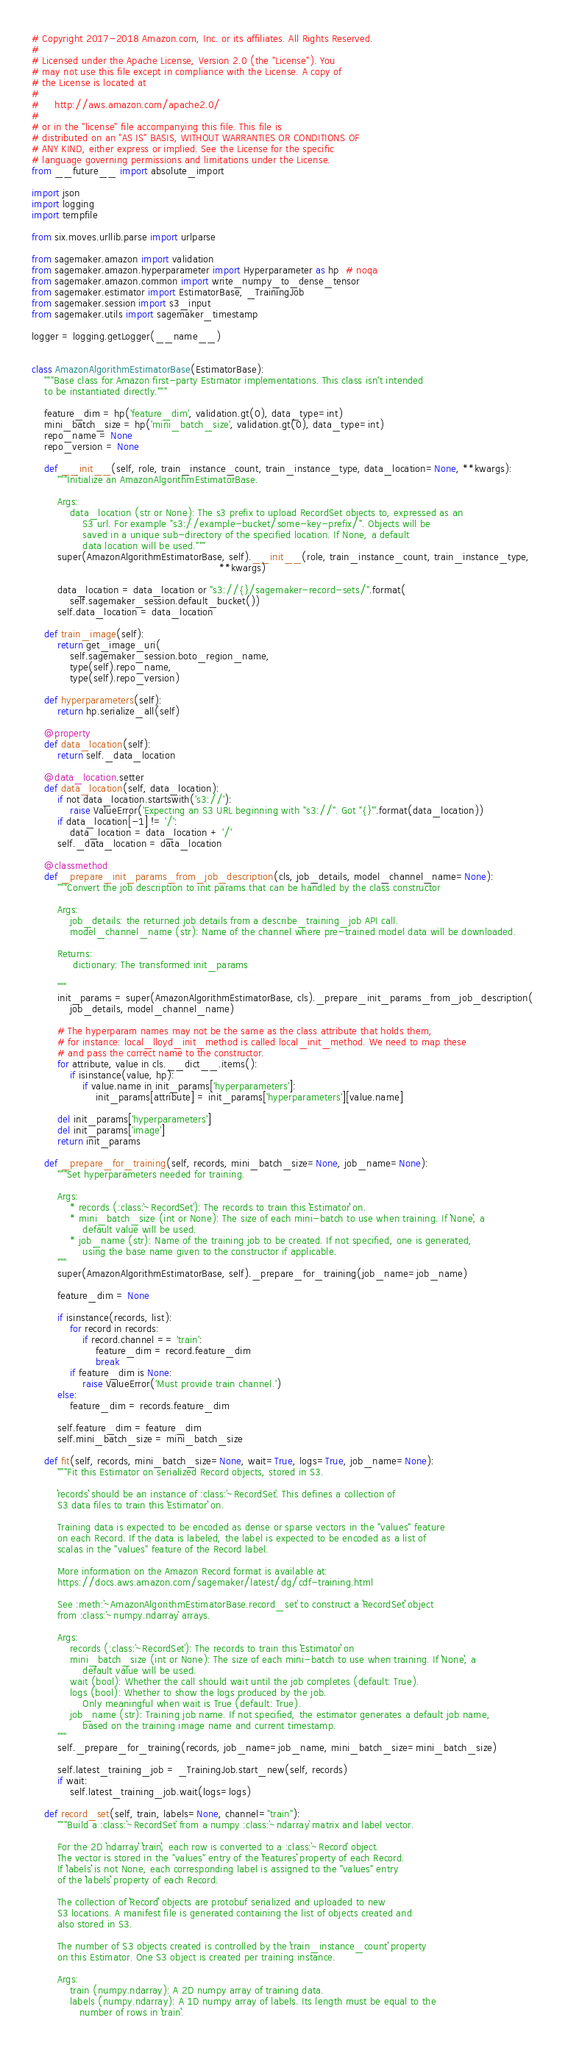<code> <loc_0><loc_0><loc_500><loc_500><_Python_># Copyright 2017-2018 Amazon.com, Inc. or its affiliates. All Rights Reserved.
#
# Licensed under the Apache License, Version 2.0 (the "License"). You
# may not use this file except in compliance with the License. A copy of
# the License is located at
#
#     http://aws.amazon.com/apache2.0/
#
# or in the "license" file accompanying this file. This file is
# distributed on an "AS IS" BASIS, WITHOUT WARRANTIES OR CONDITIONS OF
# ANY KIND, either express or implied. See the License for the specific
# language governing permissions and limitations under the License.
from __future__ import absolute_import

import json
import logging
import tempfile

from six.moves.urllib.parse import urlparse

from sagemaker.amazon import validation
from sagemaker.amazon.hyperparameter import Hyperparameter as hp  # noqa
from sagemaker.amazon.common import write_numpy_to_dense_tensor
from sagemaker.estimator import EstimatorBase, _TrainingJob
from sagemaker.session import s3_input
from sagemaker.utils import sagemaker_timestamp

logger = logging.getLogger(__name__)


class AmazonAlgorithmEstimatorBase(EstimatorBase):
    """Base class for Amazon first-party Estimator implementations. This class isn't intended
    to be instantiated directly."""

    feature_dim = hp('feature_dim', validation.gt(0), data_type=int)
    mini_batch_size = hp('mini_batch_size', validation.gt(0), data_type=int)
    repo_name = None
    repo_version = None

    def __init__(self, role, train_instance_count, train_instance_type, data_location=None, **kwargs):
        """Initialize an AmazonAlgorithmEstimatorBase.

        Args:
            data_location (str or None): The s3 prefix to upload RecordSet objects to, expressed as an
                S3 url. For example "s3://example-bucket/some-key-prefix/". Objects will be
                saved in a unique sub-directory of the specified location. If None, a default
                data location will be used."""
        super(AmazonAlgorithmEstimatorBase, self).__init__(role, train_instance_count, train_instance_type,
                                                           **kwargs)

        data_location = data_location or "s3://{}/sagemaker-record-sets/".format(
            self.sagemaker_session.default_bucket())
        self.data_location = data_location

    def train_image(self):
        return get_image_uri(
            self.sagemaker_session.boto_region_name,
            type(self).repo_name,
            type(self).repo_version)

    def hyperparameters(self):
        return hp.serialize_all(self)

    @property
    def data_location(self):
        return self._data_location

    @data_location.setter
    def data_location(self, data_location):
        if not data_location.startswith('s3://'):
            raise ValueError('Expecting an S3 URL beginning with "s3://". Got "{}"'.format(data_location))
        if data_location[-1] != '/':
            data_location = data_location + '/'
        self._data_location = data_location

    @classmethod
    def _prepare_init_params_from_job_description(cls, job_details, model_channel_name=None):
        """Convert the job description to init params that can be handled by the class constructor

        Args:
            job_details: the returned job details from a describe_training_job API call.
            model_channel_name (str): Name of the channel where pre-trained model data will be downloaded.

        Returns:
             dictionary: The transformed init_params

        """
        init_params = super(AmazonAlgorithmEstimatorBase, cls)._prepare_init_params_from_job_description(
            job_details, model_channel_name)

        # The hyperparam names may not be the same as the class attribute that holds them,
        # for instance: local_lloyd_init_method is called local_init_method. We need to map these
        # and pass the correct name to the constructor.
        for attribute, value in cls.__dict__.items():
            if isinstance(value, hp):
                if value.name in init_params['hyperparameters']:
                    init_params[attribute] = init_params['hyperparameters'][value.name]

        del init_params['hyperparameters']
        del init_params['image']
        return init_params

    def _prepare_for_training(self, records, mini_batch_size=None, job_name=None):
        """Set hyperparameters needed for training.

        Args:
            * records (:class:`~RecordSet`): The records to train this ``Estimator`` on.
            * mini_batch_size (int or None): The size of each mini-batch to use when training. If ``None``, a
                default value will be used.
            * job_name (str): Name of the training job to be created. If not specified, one is generated,
                using the base name given to the constructor if applicable.
        """
        super(AmazonAlgorithmEstimatorBase, self)._prepare_for_training(job_name=job_name)

        feature_dim = None

        if isinstance(records, list):
            for record in records:
                if record.channel == 'train':
                    feature_dim = record.feature_dim
                    break
            if feature_dim is None:
                raise ValueError('Must provide train channel.')
        else:
            feature_dim = records.feature_dim

        self.feature_dim = feature_dim
        self.mini_batch_size = mini_batch_size

    def fit(self, records, mini_batch_size=None, wait=True, logs=True, job_name=None):
        """Fit this Estimator on serialized Record objects, stored in S3.

        ``records`` should be an instance of :class:`~RecordSet`. This defines a collection of
        S3 data files to train this ``Estimator`` on.

        Training data is expected to be encoded as dense or sparse vectors in the "values" feature
        on each Record. If the data is labeled, the label is expected to be encoded as a list of
        scalas in the "values" feature of the Record label.

        More information on the Amazon Record format is available at:
        https://docs.aws.amazon.com/sagemaker/latest/dg/cdf-training.html

        See :meth:`~AmazonAlgorithmEstimatorBase.record_set` to construct a ``RecordSet`` object
        from :class:`~numpy.ndarray` arrays.

        Args:
            records (:class:`~RecordSet`): The records to train this ``Estimator`` on
            mini_batch_size (int or None): The size of each mini-batch to use when training. If ``None``, a
                default value will be used.
            wait (bool): Whether the call should wait until the job completes (default: True).
            logs (bool): Whether to show the logs produced by the job.
                Only meaningful when wait is True (default: True).
            job_name (str): Training job name. If not specified, the estimator generates a default job name,
                based on the training image name and current timestamp.
        """
        self._prepare_for_training(records, job_name=job_name, mini_batch_size=mini_batch_size)

        self.latest_training_job = _TrainingJob.start_new(self, records)
        if wait:
            self.latest_training_job.wait(logs=logs)

    def record_set(self, train, labels=None, channel="train"):
        """Build a :class:`~RecordSet` from a numpy :class:`~ndarray` matrix and label vector.

        For the 2D ``ndarray`` ``train``, each row is converted to a :class:`~Record` object.
        The vector is stored in the "values" entry of the ``features`` property of each Record.
        If ``labels`` is not None, each corresponding label is assigned to the "values" entry
        of the ``labels`` property of each Record.

        The collection of ``Record`` objects are protobuf serialized and uploaded to new
        S3 locations. A manifest file is generated containing the list of objects created and
        also stored in S3.

        The number of S3 objects created is controlled by the ``train_instance_count`` property
        on this Estimator. One S3 object is created per training instance.

        Args:
            train (numpy.ndarray): A 2D numpy array of training data.
            labels (numpy.ndarray): A 1D numpy array of labels. Its length must be equal to the
               number of rows in ``train``.</code> 